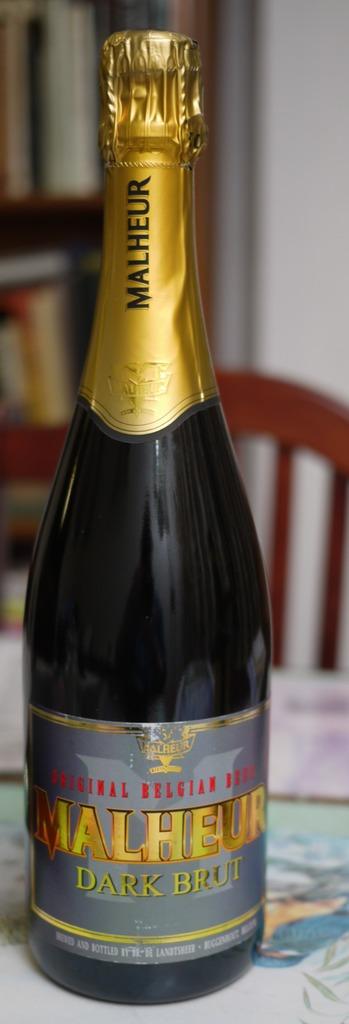What is the name of the brewery?
Your response must be concise. Malheur. 